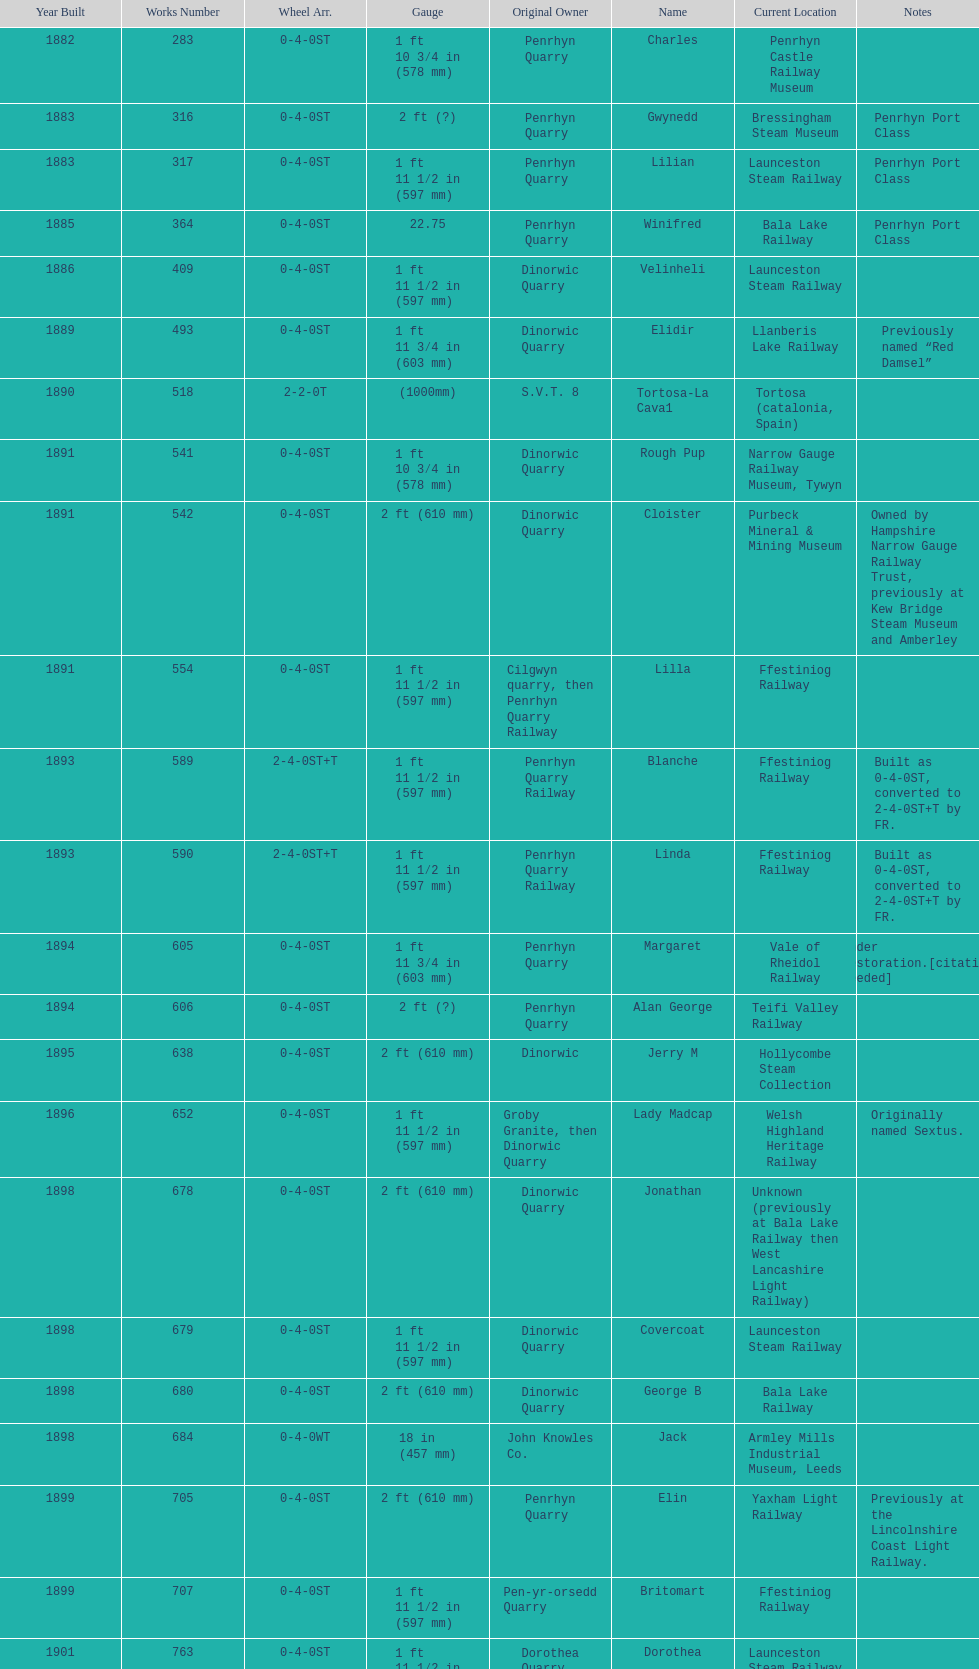Would you mind parsing the complete table? {'header': ['Year Built', 'Works Number', 'Wheel Arr.', 'Gauge', 'Original Owner', 'Name', 'Current Location', 'Notes'], 'rows': [['1882', '283', '0-4-0ST', '1\xa0ft 10\xa03⁄4\xa0in (578\xa0mm)', 'Penrhyn Quarry', 'Charles', 'Penrhyn Castle Railway Museum', ''], ['1883', '316', '0-4-0ST', '2\xa0ft (?)', 'Penrhyn Quarry', 'Gwynedd', 'Bressingham Steam Museum', 'Penrhyn Port Class'], ['1883', '317', '0-4-0ST', '1\xa0ft 11\xa01⁄2\xa0in (597\xa0mm)', 'Penrhyn Quarry', 'Lilian', 'Launceston Steam Railway', 'Penrhyn Port Class'], ['1885', '364', '0-4-0ST', '22.75', 'Penrhyn Quarry', 'Winifred', 'Bala Lake Railway', 'Penrhyn Port Class'], ['1886', '409', '0-4-0ST', '1\xa0ft 11\xa01⁄2\xa0in (597\xa0mm)', 'Dinorwic Quarry', 'Velinheli', 'Launceston Steam Railway', ''], ['1889', '493', '0-4-0ST', '1\xa0ft 11\xa03⁄4\xa0in (603\xa0mm)', 'Dinorwic Quarry', 'Elidir', 'Llanberis Lake Railway', 'Previously named “Red Damsel”'], ['1890', '518', '2-2-0T', '(1000mm)', 'S.V.T. 8', 'Tortosa-La Cava1', 'Tortosa (catalonia, Spain)', ''], ['1891', '541', '0-4-0ST', '1\xa0ft 10\xa03⁄4\xa0in (578\xa0mm)', 'Dinorwic Quarry', 'Rough Pup', 'Narrow Gauge Railway Museum, Tywyn', ''], ['1891', '542', '0-4-0ST', '2\xa0ft (610\xa0mm)', 'Dinorwic Quarry', 'Cloister', 'Purbeck Mineral & Mining Museum', 'Owned by Hampshire Narrow Gauge Railway Trust, previously at Kew Bridge Steam Museum and Amberley'], ['1891', '554', '0-4-0ST', '1\xa0ft 11\xa01⁄2\xa0in (597\xa0mm)', 'Cilgwyn quarry, then Penrhyn Quarry Railway', 'Lilla', 'Ffestiniog Railway', ''], ['1893', '589', '2-4-0ST+T', '1\xa0ft 11\xa01⁄2\xa0in (597\xa0mm)', 'Penrhyn Quarry Railway', 'Blanche', 'Ffestiniog Railway', 'Built as 0-4-0ST, converted to 2-4-0ST+T by FR.'], ['1893', '590', '2-4-0ST+T', '1\xa0ft 11\xa01⁄2\xa0in (597\xa0mm)', 'Penrhyn Quarry Railway', 'Linda', 'Ffestiniog Railway', 'Built as 0-4-0ST, converted to 2-4-0ST+T by FR.'], ['1894', '605', '0-4-0ST', '1\xa0ft 11\xa03⁄4\xa0in (603\xa0mm)', 'Penrhyn Quarry', 'Margaret', 'Vale of Rheidol Railway', 'Under restoration.[citation needed]'], ['1894', '606', '0-4-0ST', '2\xa0ft (?)', 'Penrhyn Quarry', 'Alan George', 'Teifi Valley Railway', ''], ['1895', '638', '0-4-0ST', '2\xa0ft (610\xa0mm)', 'Dinorwic', 'Jerry M', 'Hollycombe Steam Collection', ''], ['1896', '652', '0-4-0ST', '1\xa0ft 11\xa01⁄2\xa0in (597\xa0mm)', 'Groby Granite, then Dinorwic Quarry', 'Lady Madcap', 'Welsh Highland Heritage Railway', 'Originally named Sextus.'], ['1898', '678', '0-4-0ST', '2\xa0ft (610\xa0mm)', 'Dinorwic Quarry', 'Jonathan', 'Unknown (previously at Bala Lake Railway then West Lancashire Light Railway)', ''], ['1898', '679', '0-4-0ST', '1\xa0ft 11\xa01⁄2\xa0in (597\xa0mm)', 'Dinorwic Quarry', 'Covercoat', 'Launceston Steam Railway', ''], ['1898', '680', '0-4-0ST', '2\xa0ft (610\xa0mm)', 'Dinorwic Quarry', 'George B', 'Bala Lake Railway', ''], ['1898', '684', '0-4-0WT', '18\xa0in (457\xa0mm)', 'John Knowles Co.', 'Jack', 'Armley Mills Industrial Museum, Leeds', ''], ['1899', '705', '0-4-0ST', '2\xa0ft (610\xa0mm)', 'Penrhyn Quarry', 'Elin', 'Yaxham Light Railway', 'Previously at the Lincolnshire Coast Light Railway.'], ['1899', '707', '0-4-0ST', '1\xa0ft 11\xa01⁄2\xa0in (597\xa0mm)', 'Pen-yr-orsedd Quarry', 'Britomart', 'Ffestiniog Railway', ''], ['1901', '763', '0-4-0ST', '1\xa0ft 11\xa01⁄2\xa0in (597\xa0mm)', 'Dorothea Quarry', 'Dorothea', 'Launceston Steam Railway', ''], ['1902', '779', '0-4-0ST', '2\xa0ft (610\xa0mm)', 'Dinorwic Quarry', 'Holy War', 'Bala Lake Railway', ''], ['1902', '780', '0-4-0ST', '2\xa0ft (610\xa0mm)', 'Dinorwic Quarry', 'Alice', 'Bala Lake Railway', ''], ['1902', '783', '0-6-0T', '(1000mm)', 'Sociedad General de Ferrocarriles Vasco-Asturiana', 'VA-21 Nalon', 'Gijon Railway Museum (Spain)', ''], ['1903', '822', '0-4-0ST', '2\xa0ft (610\xa0mm)', 'Dinorwic Quarry', 'Maid Marian', 'Bala Lake Railway', ''], ['1903', '823', '0-4-0ST', '2\xa0ft (?)', 'Dinorwic Quarry', 'Irish Mail', 'West Lancashire Light Railway', ''], ['1903', '827', '0-4-0ST', '1\xa0ft 11\xa03⁄4\xa0in (603\xa0mm)', 'Pen-yr-orsedd Quarry', 'Sybil', 'Brecon Mountain Railway', ''], ['1904', '855', '0-4-0ST', '1\xa0ft 10\xa03⁄4\xa0in (578\xa0mm)', 'Penryn Quarry', 'Hugh Napier', 'Penrhyn Castle Railway Museum, Gwynedd', ''], ['1905', '873', '0-4-0ST', '2\xa0ft (?)', 'Pen-yr-orsedd Quarry', 'Una', 'National Slate Museum, Llanberis', ''], ['1904', '894', '0-4-0ST', '1\xa0ft 11\xa03⁄4\xa0in (603\xa0mm)', 'Dinorwic Quarry', 'Thomas Bach', 'Llanberis Lake Railway', 'Originally named “Wild Aster”'], ['1906', '901', '2-6-2T', '1\xa0ft 11\xa01⁄2\xa0in (597\xa0mm)', 'North Wales Narrow Gauge Railways', 'Russell', 'Welsh Highland Heritage Railway', ''], ['1906', '920', '0-4-0ST', '2\xa0ft (?)', 'Penrhyn Quarry', 'Pamela', 'Old Kiln Light Railway', ''], ['1909', '994', '0-4-0ST', '2\xa0ft (?)', 'Penrhyn Quarry', 'Bill Harvey', 'Bressingham Steam Museum', 'previously George Sholto'], ['1918', '1312', '4-6-0T', '1\xa0ft\xa011\xa01⁄2\xa0in (597\xa0mm)', 'British War Department\\nEFOP #203', '---', 'Pampas Safari, Gravataí, RS, Brazil', '[citation needed]'], ['1918\\nor\\n1921?', '1313', '0-6-2T', '3\xa0ft\xa03\xa03⁄8\xa0in (1,000\xa0mm)', 'British War Department\\nUsina Leão Utinga #1\\nUsina Laginha #1', '---', 'Usina Laginha, União dos Palmares, AL, Brazil', '[citation needed]'], ['1920', '1404', '0-4-0WT', '18\xa0in (457\xa0mm)', 'John Knowles Co.', 'Gwen', 'Richard Farmer current owner, Northridge, California, USA', ''], ['1922', '1429', '0-4-0ST', '2\xa0ft (610\xa0mm)', 'Dinorwic', 'Lady Joan', 'Bredgar and Wormshill Light Railway', ''], ['1922', '1430', '0-4-0ST', '1\xa0ft 11\xa03⁄4\xa0in (603\xa0mm)', 'Dinorwic Quarry', 'Dolbadarn', 'Llanberis Lake Railway', ''], ['1937', '1859', '0-4-2T', '2\xa0ft (?)', 'Umtwalumi Valley Estate, Natal', '16 Carlisle', 'South Tynedale Railway', ''], ['1940', '2075', '0-4-2T', '2\xa0ft (?)', 'Chaka’s Kraal Sugar Estates, Natal', 'Chaka’s Kraal No. 6', 'North Gloucestershire Railway', ''], ['1954', '3815', '2-6-2T', '2\xa0ft 6\xa0in (762\xa0mm)', 'Sierra Leone Government Railway', '14', 'Welshpool and Llanfair Light Railway', ''], ['1971', '3902', '0-4-2ST', '2\xa0ft (610\xa0mm)', 'Trangkil Sugar Mill, Indonesia', 'Trangkil No.4', 'Statfold Barn Railway', 'Converted from 750\xa0mm (2\xa0ft\xa05\xa01⁄2\xa0in) gauge. Last steam locomotive to be built by Hunslet, and the last industrial steam locomotive built in Britain.']]} What is the dissimilarity in gauge between works numbers 541 and 542? 32 mm. 